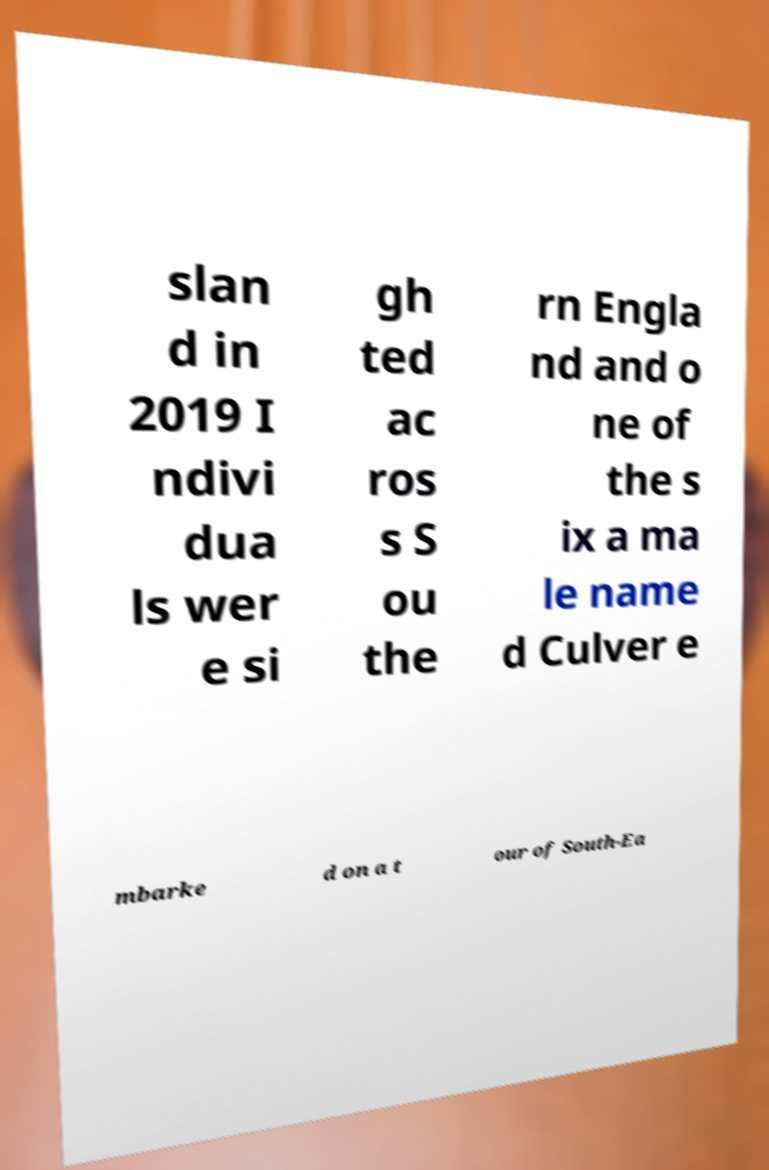There's text embedded in this image that I need extracted. Can you transcribe it verbatim? slan d in 2019 I ndivi dua ls wer e si gh ted ac ros s S ou the rn Engla nd and o ne of the s ix a ma le name d Culver e mbarke d on a t our of South-Ea 